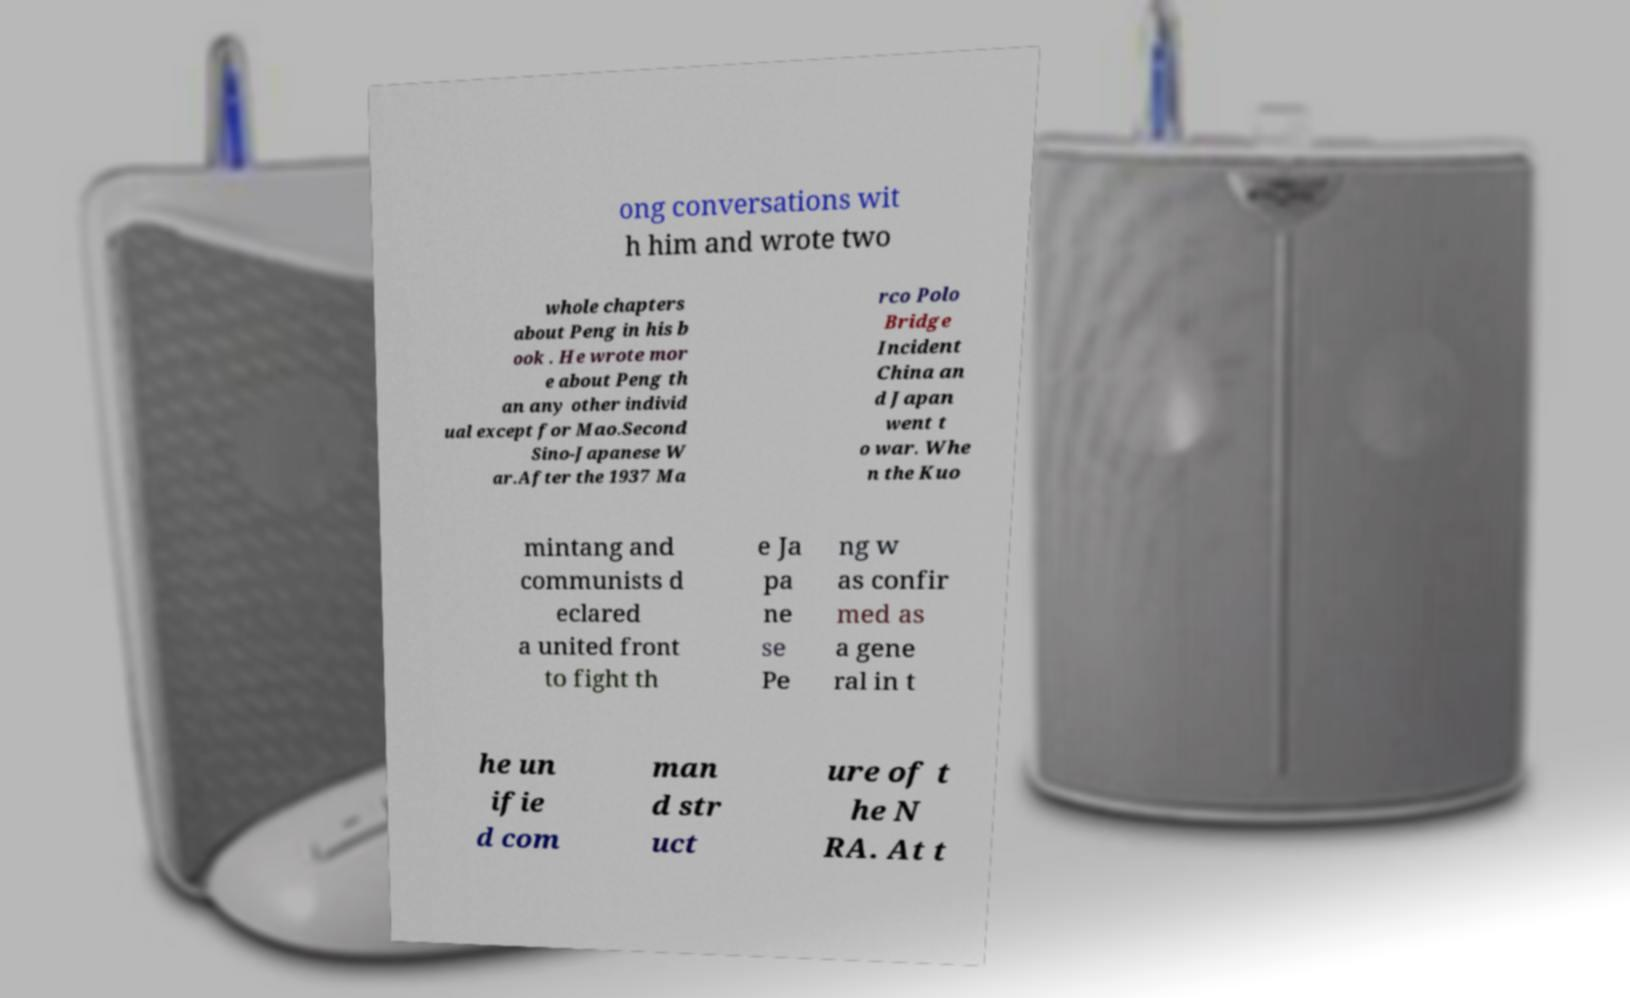Please read and relay the text visible in this image. What does it say? ong conversations wit h him and wrote two whole chapters about Peng in his b ook . He wrote mor e about Peng th an any other individ ual except for Mao.Second Sino-Japanese W ar.After the 1937 Ma rco Polo Bridge Incident China an d Japan went t o war. Whe n the Kuo mintang and communists d eclared a united front to fight th e Ja pa ne se Pe ng w as confir med as a gene ral in t he un ifie d com man d str uct ure of t he N RA. At t 